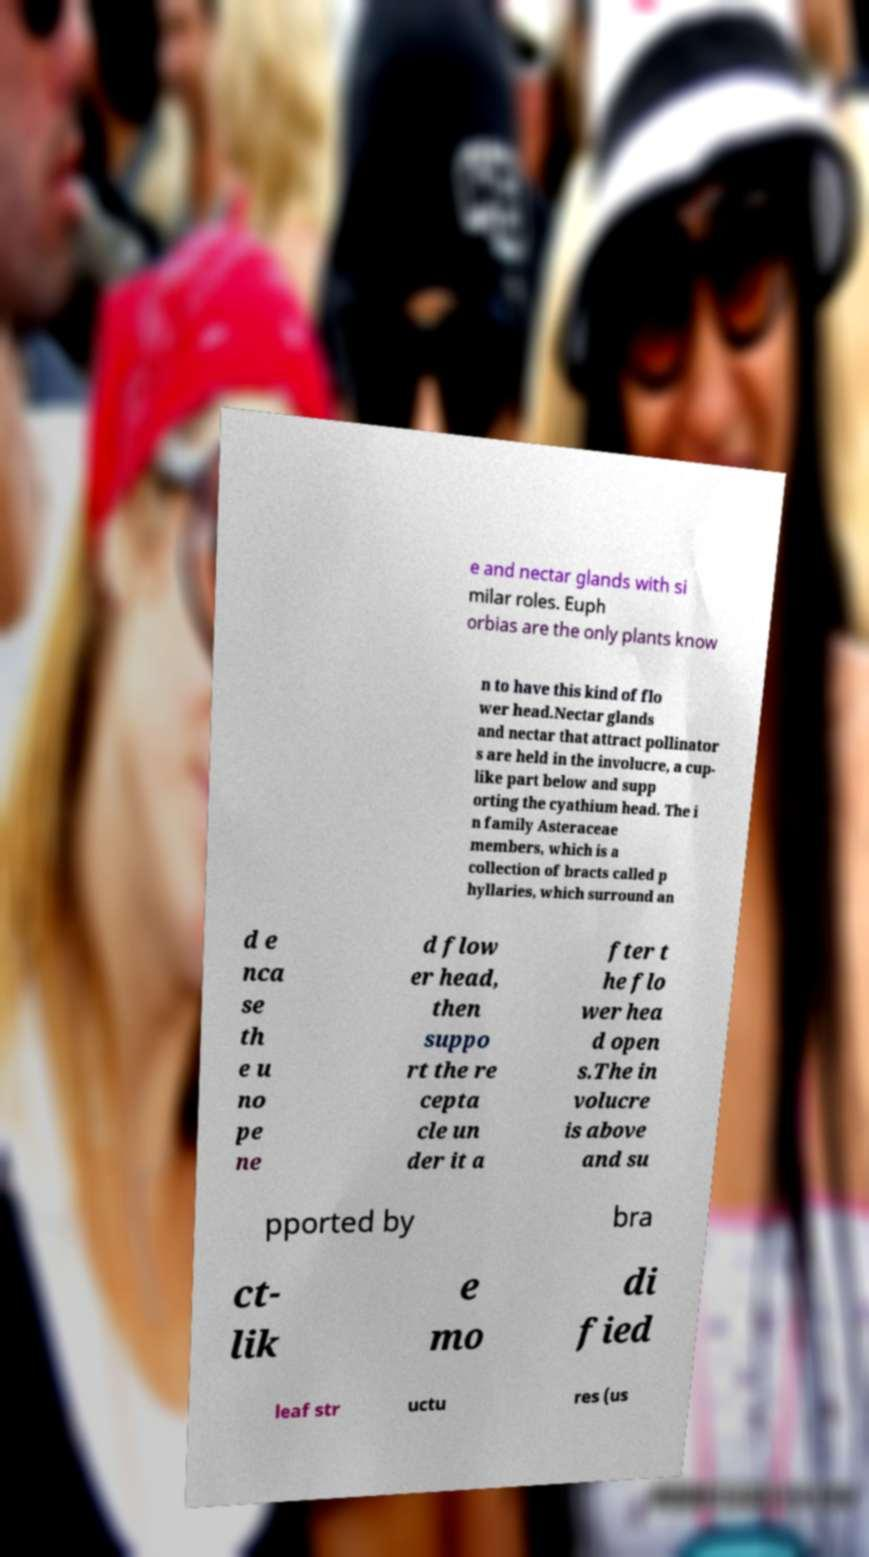For documentation purposes, I need the text within this image transcribed. Could you provide that? e and nectar glands with si milar roles. Euph orbias are the only plants know n to have this kind of flo wer head.Nectar glands and nectar that attract pollinator s are held in the involucre, a cup- like part below and supp orting the cyathium head. The i n family Asteraceae members, which is a collection of bracts called p hyllaries, which surround an d e nca se th e u no pe ne d flow er head, then suppo rt the re cepta cle un der it a fter t he flo wer hea d open s.The in volucre is above and su pported by bra ct- lik e mo di fied leaf str uctu res (us 